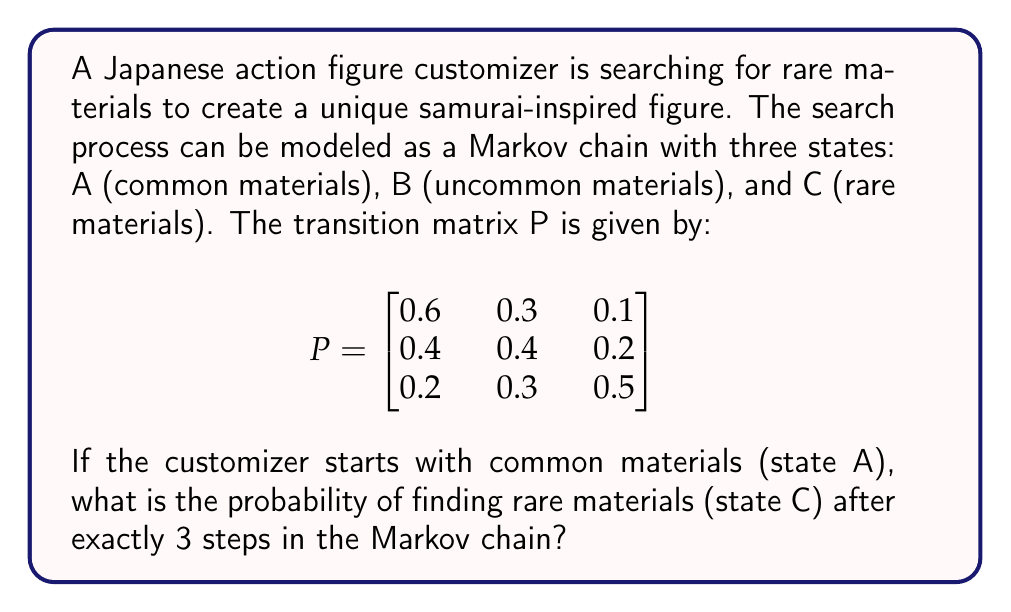Teach me how to tackle this problem. To solve this problem, we need to calculate the 3-step transition probability from state A to state C. We can do this by raising the transition matrix P to the power of 3 and then looking at the element in the first row, third column.

Step 1: Calculate $P^3$
$$P^3 = P \times P \times P$$

We can use matrix multiplication to compute this:

$$P^2 = \begin{bmatrix}
0.6 & 0.3 & 0.1 \\
0.4 & 0.4 & 0.2 \\
0.2 & 0.3 & 0.5
\end{bmatrix} \times \begin{bmatrix}
0.6 & 0.3 & 0.1 \\
0.4 & 0.4 & 0.2 \\
0.2 & 0.3 & 0.5
\end{bmatrix} = \begin{bmatrix}
0.52 & 0.33 & 0.15 \\
0.48 & 0.37 & 0.15 \\
0.38 & 0.36 & 0.26
\end{bmatrix}$$

Now, we multiply $P^2$ by P:

$$P^3 = \begin{bmatrix}
0.52 & 0.33 & 0.15 \\
0.48 & 0.37 & 0.15 \\
0.38 & 0.36 & 0.26
\end{bmatrix} \times \begin{bmatrix}
0.6 & 0.3 & 0.1 \\
0.4 & 0.4 & 0.2 \\
0.2 & 0.3 & 0.5
\end{bmatrix} = \begin{bmatrix}
0.488 & 0.339 & 0.173 \\
0.472 & 0.351 & 0.177 \\
0.428 & 0.348 & 0.224
\end{bmatrix}$$

Step 2: Identify the probability
The probability of transitioning from state A to state C in exactly 3 steps is given by the element in the first row, third column of $P^3$, which is 0.173.

Therefore, the probability of finding rare materials (state C) after exactly 3 steps, starting from common materials (state A), is 0.173 or 17.3%.
Answer: 0.173 